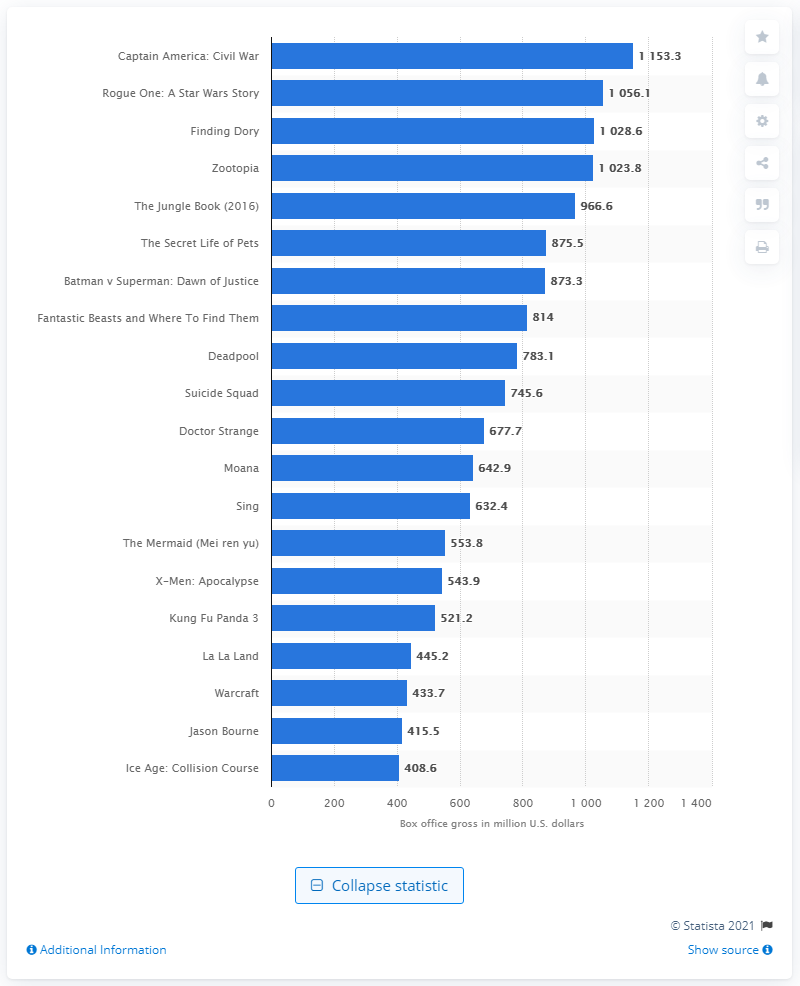Mention a couple of crucial points in this snapshot. In 2016, the highest grossing movie was "Captain America: Civil War," which generated a significant amount of revenue. The worldwide box office revenue of Captain America: Civil War was 1153.3 million dollars. 